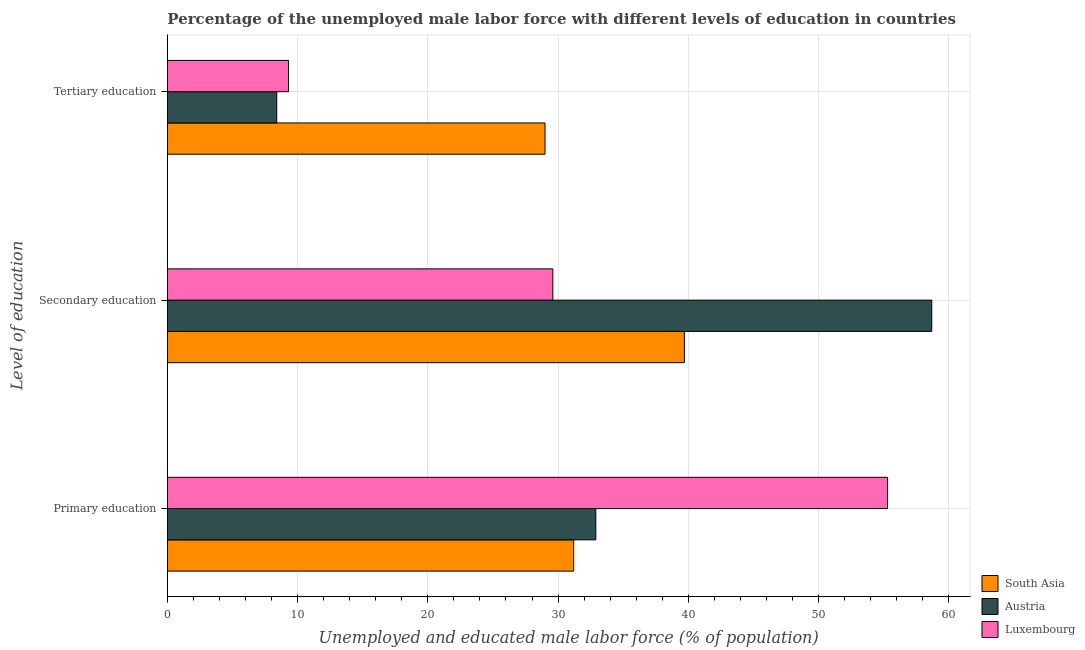Are the number of bars on each tick of the Y-axis equal?
Make the answer very short. Yes. What is the label of the 2nd group of bars from the top?
Your response must be concise. Secondary education. What is the percentage of male labor force who received tertiary education in Austria?
Keep it short and to the point. 8.4. Across all countries, what is the maximum percentage of male labor force who received secondary education?
Give a very brief answer. 58.7. Across all countries, what is the minimum percentage of male labor force who received secondary education?
Your response must be concise. 29.6. In which country was the percentage of male labor force who received tertiary education maximum?
Your response must be concise. South Asia. In which country was the percentage of male labor force who received secondary education minimum?
Your response must be concise. Luxembourg. What is the total percentage of male labor force who received primary education in the graph?
Provide a succinct answer. 119.4. What is the difference between the percentage of male labor force who received secondary education in Austria and that in South Asia?
Your answer should be very brief. 19. What is the difference between the percentage of male labor force who received secondary education in Austria and the percentage of male labor force who received primary education in Luxembourg?
Give a very brief answer. 3.4. What is the average percentage of male labor force who received secondary education per country?
Provide a short and direct response. 42.67. What is the difference between the percentage of male labor force who received tertiary education and percentage of male labor force who received secondary education in Austria?
Your answer should be compact. -50.3. What is the ratio of the percentage of male labor force who received secondary education in South Asia to that in Austria?
Your answer should be very brief. 0.68. Is the difference between the percentage of male labor force who received tertiary education in Austria and Luxembourg greater than the difference between the percentage of male labor force who received primary education in Austria and Luxembourg?
Your answer should be compact. Yes. What is the difference between the highest and the second highest percentage of male labor force who received tertiary education?
Give a very brief answer. 19.7. What is the difference between the highest and the lowest percentage of male labor force who received primary education?
Provide a short and direct response. 24.1. In how many countries, is the percentage of male labor force who received tertiary education greater than the average percentage of male labor force who received tertiary education taken over all countries?
Offer a very short reply. 1. What does the 3rd bar from the top in Secondary education represents?
Provide a succinct answer. South Asia. What does the 3rd bar from the bottom in Secondary education represents?
Provide a succinct answer. Luxembourg. Is it the case that in every country, the sum of the percentage of male labor force who received primary education and percentage of male labor force who received secondary education is greater than the percentage of male labor force who received tertiary education?
Your response must be concise. Yes. Are all the bars in the graph horizontal?
Offer a very short reply. Yes. How many countries are there in the graph?
Provide a succinct answer. 3. What is the difference between two consecutive major ticks on the X-axis?
Give a very brief answer. 10. Are the values on the major ticks of X-axis written in scientific E-notation?
Provide a succinct answer. No. Does the graph contain grids?
Provide a short and direct response. Yes. How many legend labels are there?
Your answer should be very brief. 3. What is the title of the graph?
Your answer should be compact. Percentage of the unemployed male labor force with different levels of education in countries. Does "South Sudan" appear as one of the legend labels in the graph?
Ensure brevity in your answer.  No. What is the label or title of the X-axis?
Your answer should be compact. Unemployed and educated male labor force (% of population). What is the label or title of the Y-axis?
Offer a terse response. Level of education. What is the Unemployed and educated male labor force (% of population) in South Asia in Primary education?
Keep it short and to the point. 31.2. What is the Unemployed and educated male labor force (% of population) in Austria in Primary education?
Give a very brief answer. 32.9. What is the Unemployed and educated male labor force (% of population) in Luxembourg in Primary education?
Offer a very short reply. 55.3. What is the Unemployed and educated male labor force (% of population) in South Asia in Secondary education?
Your answer should be very brief. 39.7. What is the Unemployed and educated male labor force (% of population) of Austria in Secondary education?
Provide a succinct answer. 58.7. What is the Unemployed and educated male labor force (% of population) of Luxembourg in Secondary education?
Make the answer very short. 29.6. What is the Unemployed and educated male labor force (% of population) in Austria in Tertiary education?
Provide a short and direct response. 8.4. What is the Unemployed and educated male labor force (% of population) in Luxembourg in Tertiary education?
Give a very brief answer. 9.3. Across all Level of education, what is the maximum Unemployed and educated male labor force (% of population) of South Asia?
Keep it short and to the point. 39.7. Across all Level of education, what is the maximum Unemployed and educated male labor force (% of population) in Austria?
Give a very brief answer. 58.7. Across all Level of education, what is the maximum Unemployed and educated male labor force (% of population) in Luxembourg?
Make the answer very short. 55.3. Across all Level of education, what is the minimum Unemployed and educated male labor force (% of population) in South Asia?
Keep it short and to the point. 29. Across all Level of education, what is the minimum Unemployed and educated male labor force (% of population) of Austria?
Keep it short and to the point. 8.4. Across all Level of education, what is the minimum Unemployed and educated male labor force (% of population) of Luxembourg?
Provide a short and direct response. 9.3. What is the total Unemployed and educated male labor force (% of population) in South Asia in the graph?
Offer a very short reply. 99.9. What is the total Unemployed and educated male labor force (% of population) in Austria in the graph?
Keep it short and to the point. 100. What is the total Unemployed and educated male labor force (% of population) of Luxembourg in the graph?
Offer a terse response. 94.2. What is the difference between the Unemployed and educated male labor force (% of population) in Austria in Primary education and that in Secondary education?
Provide a short and direct response. -25.8. What is the difference between the Unemployed and educated male labor force (% of population) of Luxembourg in Primary education and that in Secondary education?
Keep it short and to the point. 25.7. What is the difference between the Unemployed and educated male labor force (% of population) in South Asia in Primary education and that in Tertiary education?
Your response must be concise. 2.2. What is the difference between the Unemployed and educated male labor force (% of population) in Luxembourg in Primary education and that in Tertiary education?
Ensure brevity in your answer.  46. What is the difference between the Unemployed and educated male labor force (% of population) in South Asia in Secondary education and that in Tertiary education?
Provide a short and direct response. 10.7. What is the difference between the Unemployed and educated male labor force (% of population) of Austria in Secondary education and that in Tertiary education?
Ensure brevity in your answer.  50.3. What is the difference between the Unemployed and educated male labor force (% of population) in Luxembourg in Secondary education and that in Tertiary education?
Your answer should be compact. 20.3. What is the difference between the Unemployed and educated male labor force (% of population) in South Asia in Primary education and the Unemployed and educated male labor force (% of population) in Austria in Secondary education?
Offer a terse response. -27.5. What is the difference between the Unemployed and educated male labor force (% of population) of South Asia in Primary education and the Unemployed and educated male labor force (% of population) of Austria in Tertiary education?
Your answer should be compact. 22.8. What is the difference between the Unemployed and educated male labor force (% of population) of South Asia in Primary education and the Unemployed and educated male labor force (% of population) of Luxembourg in Tertiary education?
Provide a succinct answer. 21.9. What is the difference between the Unemployed and educated male labor force (% of population) of Austria in Primary education and the Unemployed and educated male labor force (% of population) of Luxembourg in Tertiary education?
Your response must be concise. 23.6. What is the difference between the Unemployed and educated male labor force (% of population) of South Asia in Secondary education and the Unemployed and educated male labor force (% of population) of Austria in Tertiary education?
Your answer should be very brief. 31.3. What is the difference between the Unemployed and educated male labor force (% of population) of South Asia in Secondary education and the Unemployed and educated male labor force (% of population) of Luxembourg in Tertiary education?
Give a very brief answer. 30.4. What is the difference between the Unemployed and educated male labor force (% of population) of Austria in Secondary education and the Unemployed and educated male labor force (% of population) of Luxembourg in Tertiary education?
Your answer should be very brief. 49.4. What is the average Unemployed and educated male labor force (% of population) of South Asia per Level of education?
Make the answer very short. 33.3. What is the average Unemployed and educated male labor force (% of population) in Austria per Level of education?
Your response must be concise. 33.33. What is the average Unemployed and educated male labor force (% of population) of Luxembourg per Level of education?
Offer a very short reply. 31.4. What is the difference between the Unemployed and educated male labor force (% of population) in South Asia and Unemployed and educated male labor force (% of population) in Luxembourg in Primary education?
Your answer should be very brief. -24.1. What is the difference between the Unemployed and educated male labor force (% of population) of Austria and Unemployed and educated male labor force (% of population) of Luxembourg in Primary education?
Provide a succinct answer. -22.4. What is the difference between the Unemployed and educated male labor force (% of population) in South Asia and Unemployed and educated male labor force (% of population) in Austria in Secondary education?
Provide a succinct answer. -19. What is the difference between the Unemployed and educated male labor force (% of population) in South Asia and Unemployed and educated male labor force (% of population) in Luxembourg in Secondary education?
Provide a succinct answer. 10.1. What is the difference between the Unemployed and educated male labor force (% of population) of Austria and Unemployed and educated male labor force (% of population) of Luxembourg in Secondary education?
Provide a short and direct response. 29.1. What is the difference between the Unemployed and educated male labor force (% of population) in South Asia and Unemployed and educated male labor force (% of population) in Austria in Tertiary education?
Your response must be concise. 20.6. What is the difference between the Unemployed and educated male labor force (% of population) of South Asia and Unemployed and educated male labor force (% of population) of Luxembourg in Tertiary education?
Keep it short and to the point. 19.7. What is the difference between the Unemployed and educated male labor force (% of population) in Austria and Unemployed and educated male labor force (% of population) in Luxembourg in Tertiary education?
Provide a succinct answer. -0.9. What is the ratio of the Unemployed and educated male labor force (% of population) in South Asia in Primary education to that in Secondary education?
Your answer should be very brief. 0.79. What is the ratio of the Unemployed and educated male labor force (% of population) in Austria in Primary education to that in Secondary education?
Offer a terse response. 0.56. What is the ratio of the Unemployed and educated male labor force (% of population) of Luxembourg in Primary education to that in Secondary education?
Provide a short and direct response. 1.87. What is the ratio of the Unemployed and educated male labor force (% of population) in South Asia in Primary education to that in Tertiary education?
Offer a terse response. 1.08. What is the ratio of the Unemployed and educated male labor force (% of population) in Austria in Primary education to that in Tertiary education?
Your answer should be compact. 3.92. What is the ratio of the Unemployed and educated male labor force (% of population) of Luxembourg in Primary education to that in Tertiary education?
Keep it short and to the point. 5.95. What is the ratio of the Unemployed and educated male labor force (% of population) in South Asia in Secondary education to that in Tertiary education?
Your answer should be compact. 1.37. What is the ratio of the Unemployed and educated male labor force (% of population) of Austria in Secondary education to that in Tertiary education?
Provide a short and direct response. 6.99. What is the ratio of the Unemployed and educated male labor force (% of population) in Luxembourg in Secondary education to that in Tertiary education?
Offer a very short reply. 3.18. What is the difference between the highest and the second highest Unemployed and educated male labor force (% of population) in South Asia?
Your answer should be very brief. 8.5. What is the difference between the highest and the second highest Unemployed and educated male labor force (% of population) in Austria?
Make the answer very short. 25.8. What is the difference between the highest and the second highest Unemployed and educated male labor force (% of population) of Luxembourg?
Ensure brevity in your answer.  25.7. What is the difference between the highest and the lowest Unemployed and educated male labor force (% of population) in Austria?
Provide a succinct answer. 50.3. What is the difference between the highest and the lowest Unemployed and educated male labor force (% of population) of Luxembourg?
Your response must be concise. 46. 